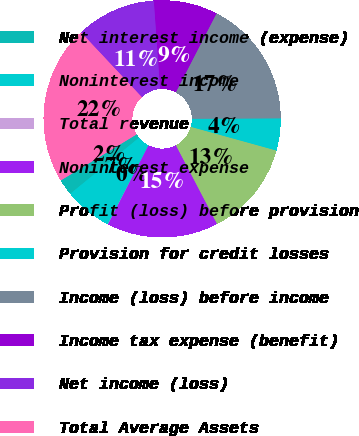Convert chart to OTSL. <chart><loc_0><loc_0><loc_500><loc_500><pie_chart><fcel>Net interest income (expense)<fcel>Noninterest income<fcel>Total revenue<fcel>Noninterest expense<fcel>Profit (loss) before provision<fcel>Provision for credit losses<fcel>Income (loss) before income<fcel>Income tax expense (benefit)<fcel>Net income (loss)<fcel>Total Average Assets<nl><fcel>2.2%<fcel>6.54%<fcel>0.04%<fcel>15.2%<fcel>13.03%<fcel>4.37%<fcel>17.36%<fcel>8.7%<fcel>10.87%<fcel>21.69%<nl></chart> 